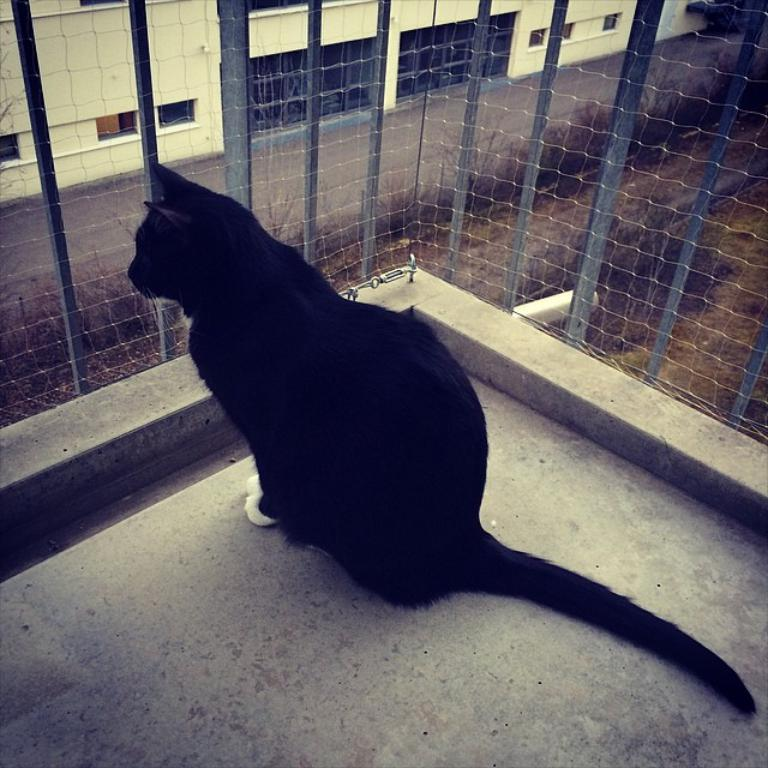What animal can be seen on the surface in the image? There is a cat on the surface in the image. What type of barrier is present in the image? There is a fence in the image. What can be seen on the ground in the image? The ground is visible in the image, with some grass and plants. What type of structure is present in the image? There is a wall in the image. What type of man-made structure is present in the image? There is a building in the image. What type of wine is being served in the image? There is no wine present in the image; it features a cat, fence, ground, wall, and building. 